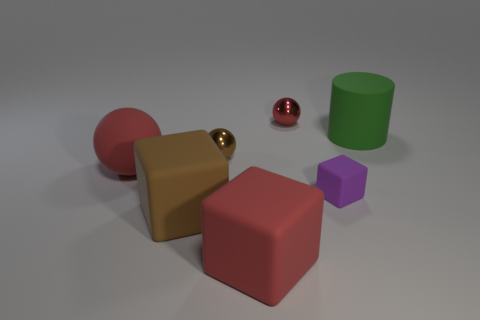Add 3 tiny purple rubber objects. How many objects exist? 10 Subtract all gray cylinders. How many red spheres are left? 2 Subtract all small spheres. How many spheres are left? 1 Subtract 1 balls. How many balls are left? 2 Subtract all cubes. How many objects are left? 4 Add 6 tiny brown metallic spheres. How many tiny brown metallic spheres are left? 7 Add 1 big objects. How many big objects exist? 5 Subtract 1 green cylinders. How many objects are left? 6 Subtract all cyan balls. Subtract all gray cylinders. How many balls are left? 3 Subtract all brown shiny spheres. Subtract all small rubber cubes. How many objects are left? 5 